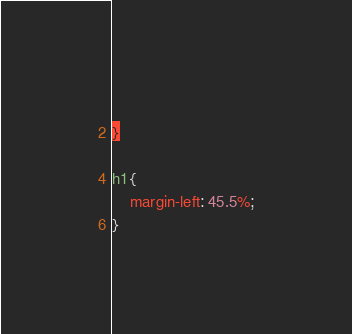<code> <loc_0><loc_0><loc_500><loc_500><_CSS_>    
}

h1{
    margin-left: 45.5%;
}

</code> 